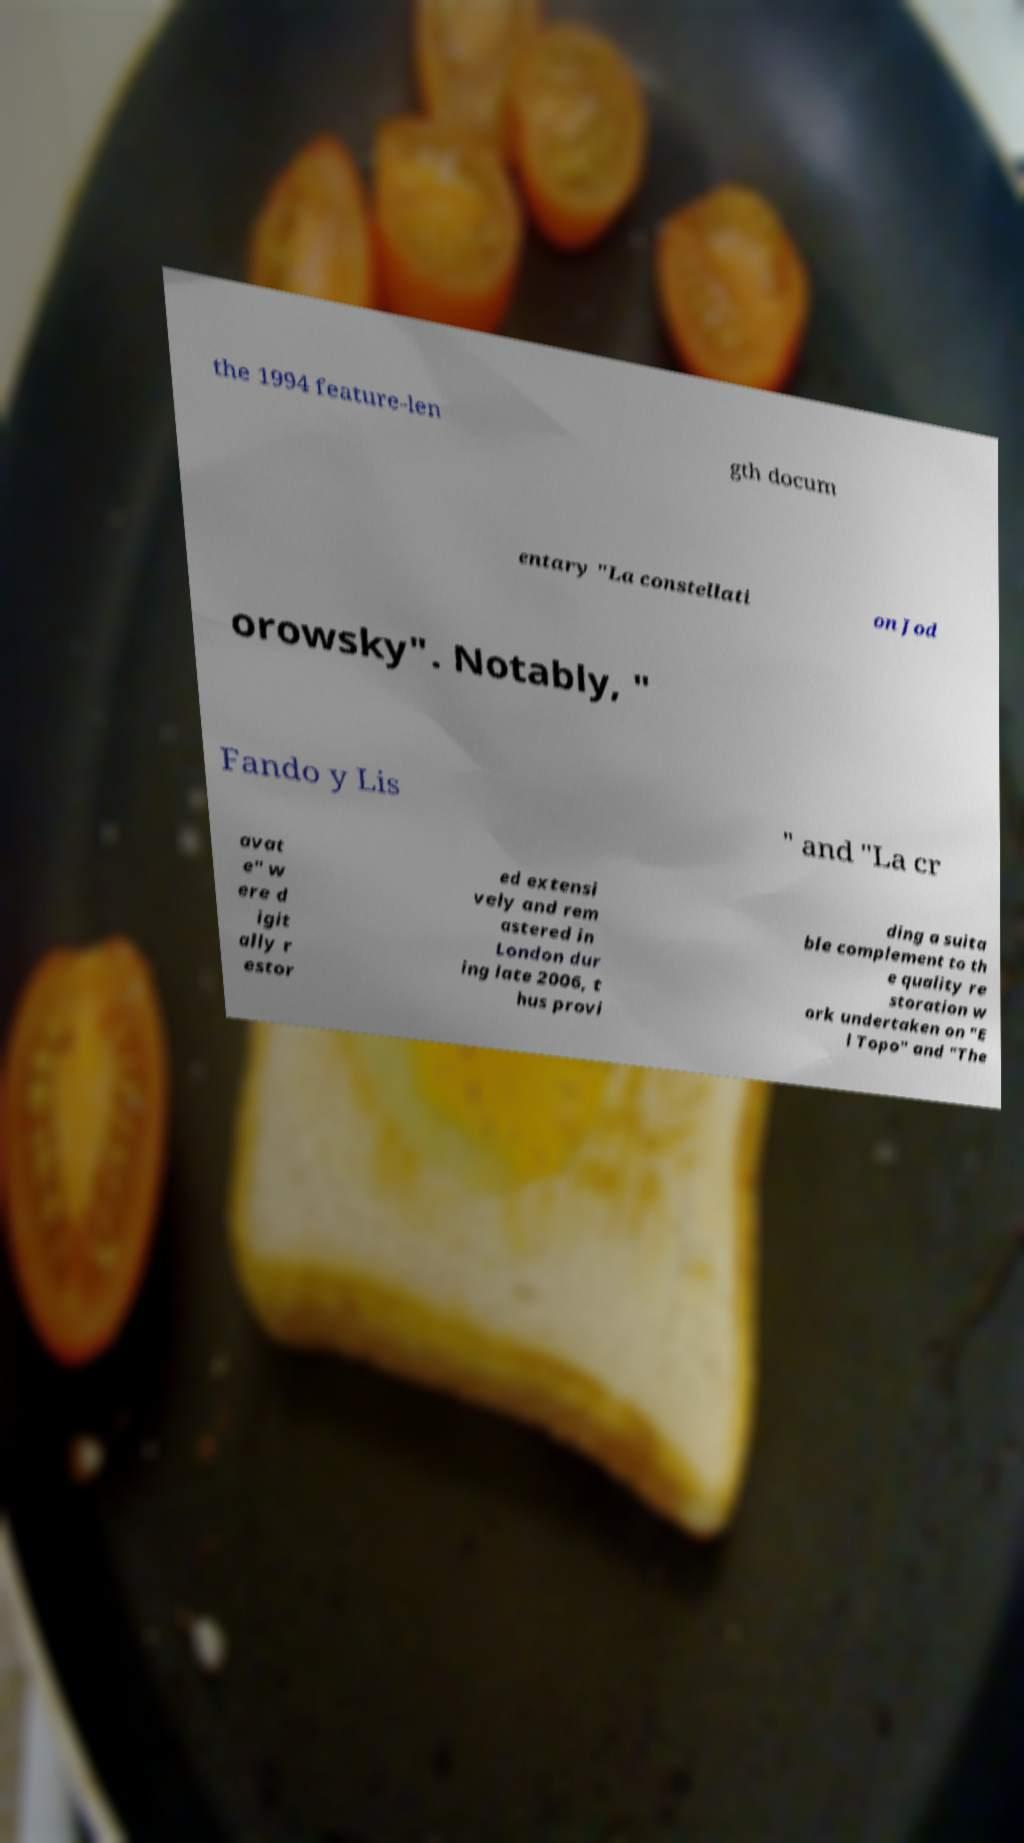There's text embedded in this image that I need extracted. Can you transcribe it verbatim? the 1994 feature-len gth docum entary "La constellati on Jod orowsky". Notably, " Fando y Lis " and "La cr avat e" w ere d igit ally r estor ed extensi vely and rem astered in London dur ing late 2006, t hus provi ding a suita ble complement to th e quality re storation w ork undertaken on "E l Topo" and "The 